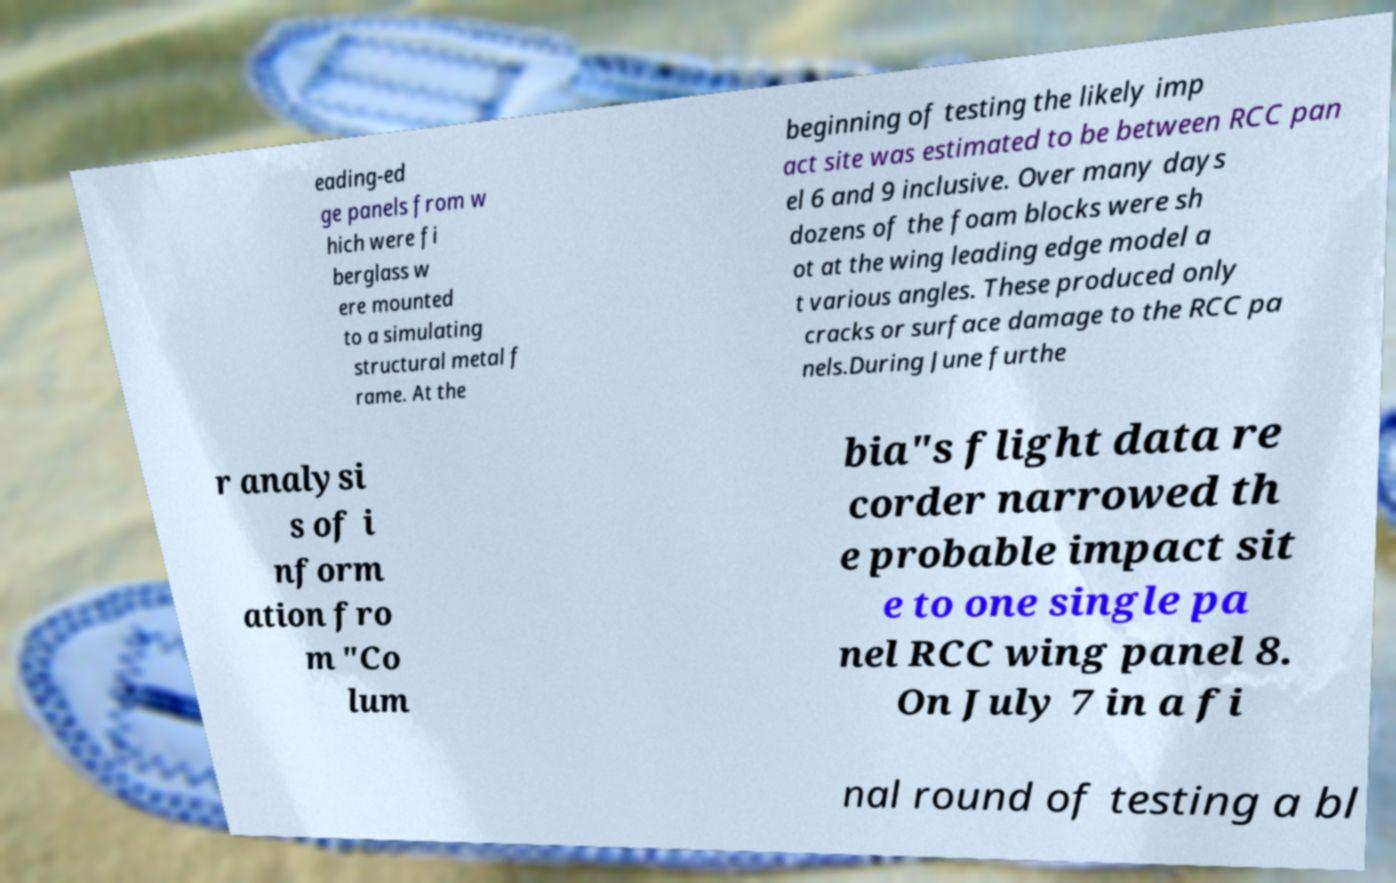What messages or text are displayed in this image? I need them in a readable, typed format. eading-ed ge panels from w hich were fi berglass w ere mounted to a simulating structural metal f rame. At the beginning of testing the likely imp act site was estimated to be between RCC pan el 6 and 9 inclusive. Over many days dozens of the foam blocks were sh ot at the wing leading edge model a t various angles. These produced only cracks or surface damage to the RCC pa nels.During June furthe r analysi s of i nform ation fro m "Co lum bia"s flight data re corder narrowed th e probable impact sit e to one single pa nel RCC wing panel 8. On July 7 in a fi nal round of testing a bl 